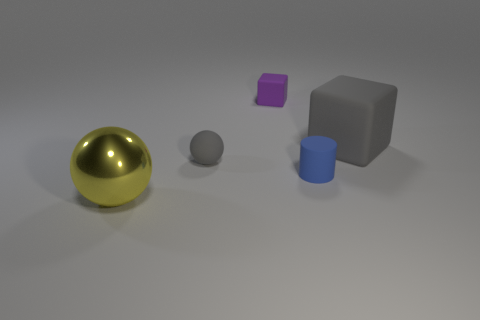There is a sphere that is the same color as the big matte block; what is it made of?
Your answer should be very brief. Rubber. There is a big object in front of the rubber sphere; what color is it?
Give a very brief answer. Yellow. What number of small metallic cubes are there?
Your answer should be very brief. 0. Are there any objects behind the sphere that is right of the sphere that is to the left of the small ball?
Provide a short and direct response. Yes. There is a blue thing that is the same size as the gray ball; what is its shape?
Provide a short and direct response. Cylinder. What number of other things are the same color as the large cube?
Provide a short and direct response. 1. What material is the gray cube?
Provide a short and direct response. Rubber. What number of other things are the same material as the tiny sphere?
Your answer should be very brief. 3. How big is the thing that is to the left of the tiny purple block and behind the big ball?
Your response must be concise. Small. What is the shape of the big thing that is behind the object in front of the blue matte cylinder?
Provide a short and direct response. Cube. 